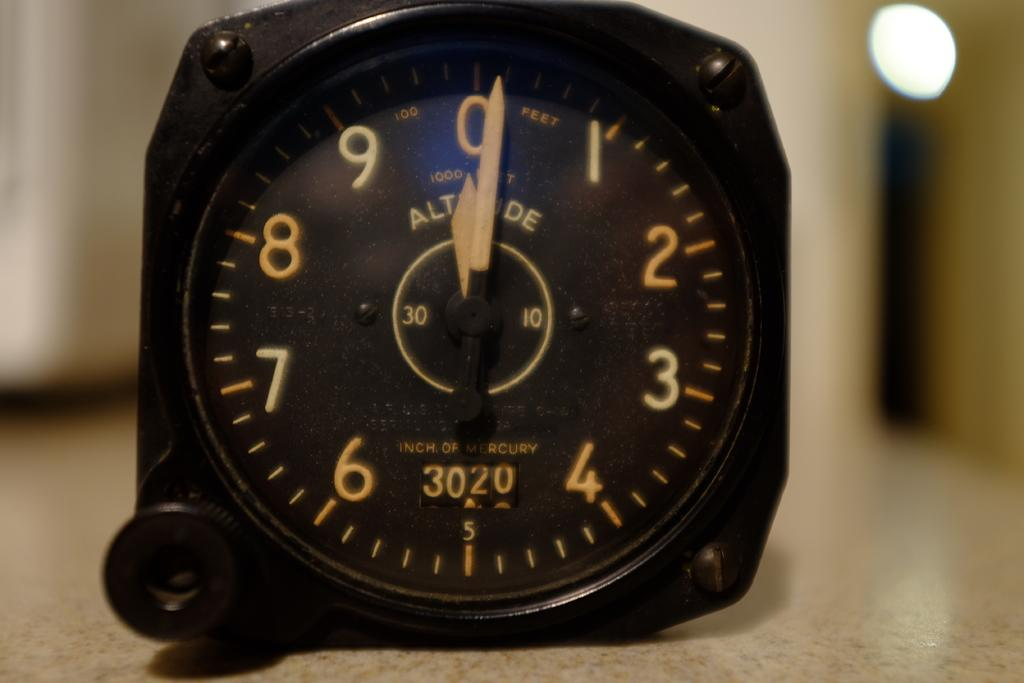<image>
Present a compact description of the photo's key features. A black clock on a table points to the number 0 